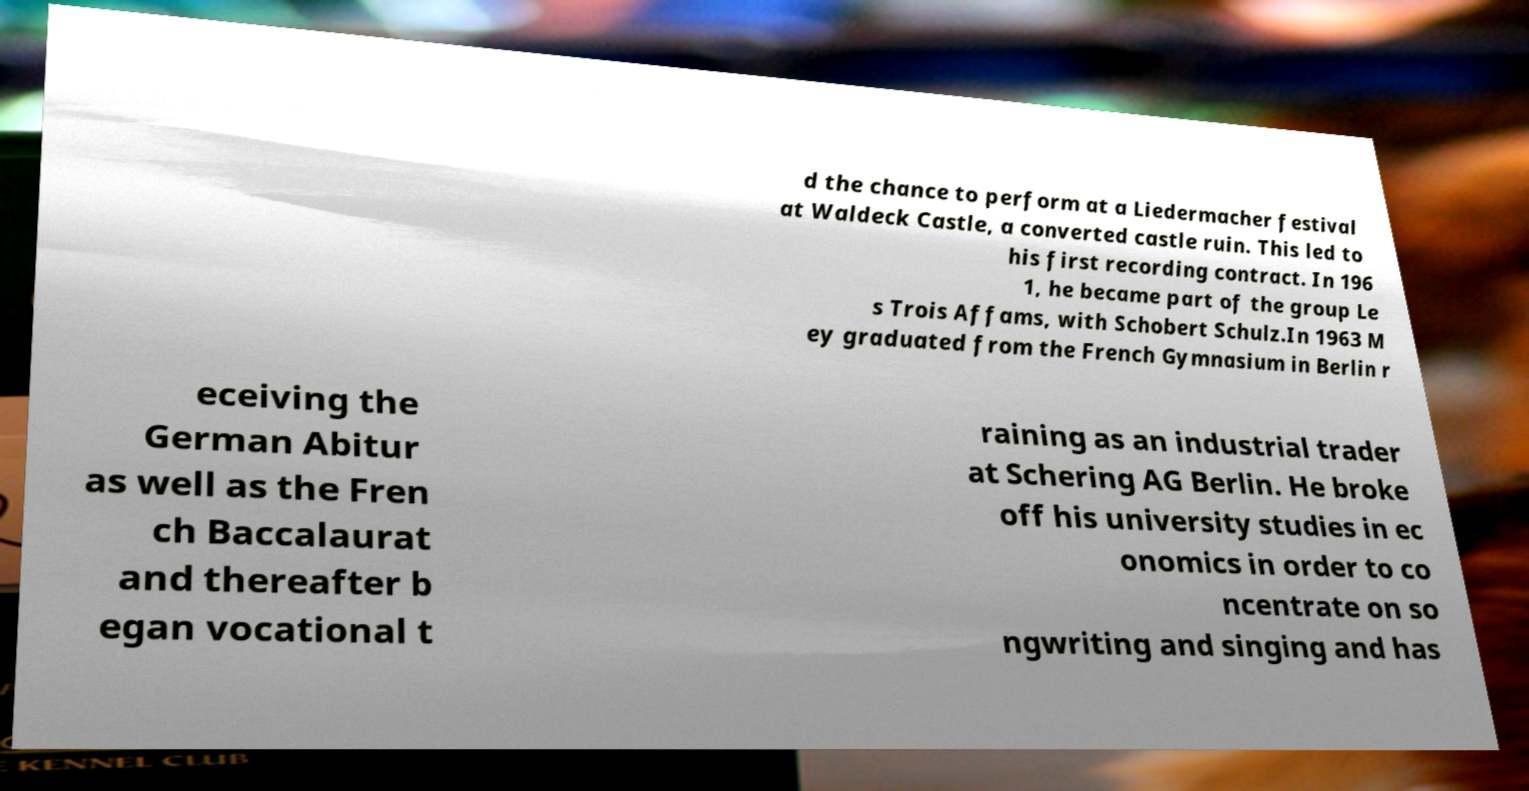For documentation purposes, I need the text within this image transcribed. Could you provide that? d the chance to perform at a Liedermacher festival at Waldeck Castle, a converted castle ruin. This led to his first recording contract. In 196 1, he became part of the group Le s Trois Affams, with Schobert Schulz.In 1963 M ey graduated from the French Gymnasium in Berlin r eceiving the German Abitur as well as the Fren ch Baccalaurat and thereafter b egan vocational t raining as an industrial trader at Schering AG Berlin. He broke off his university studies in ec onomics in order to co ncentrate on so ngwriting and singing and has 